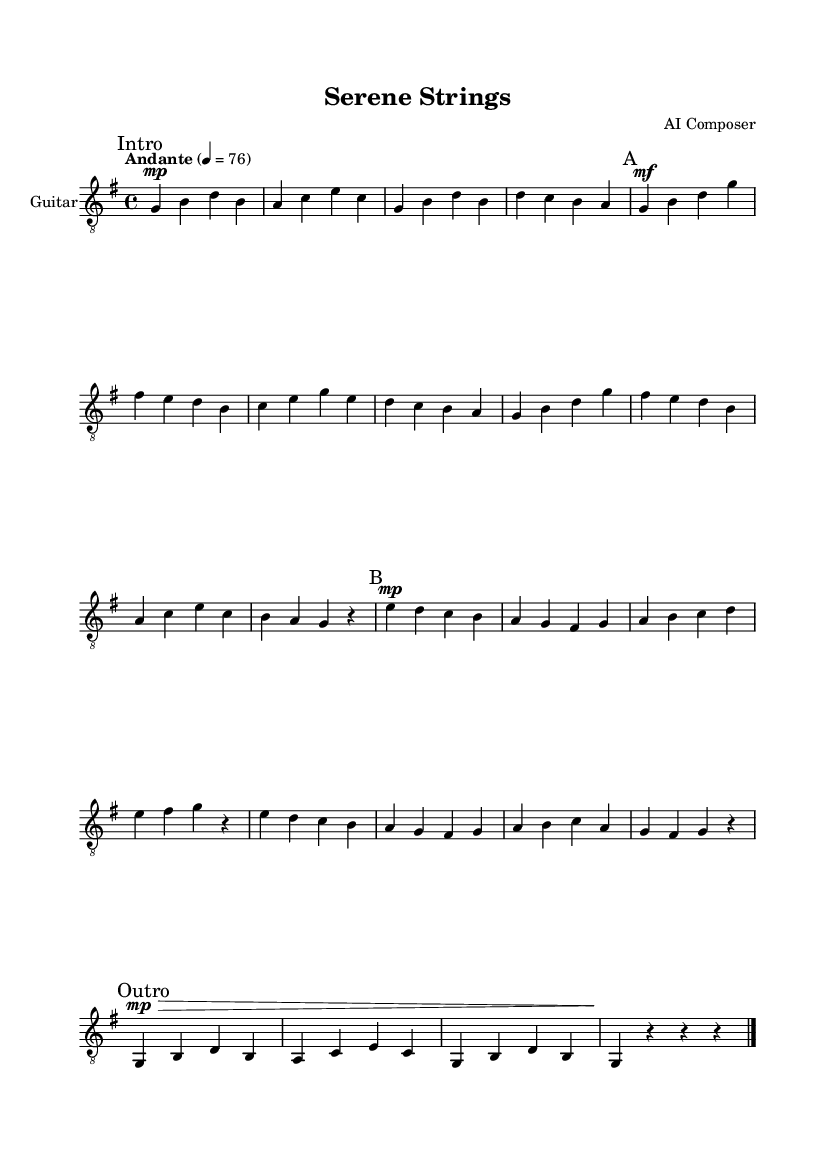What is the key signature of this music? The key signature is G major, which has one sharp (F#). This can be determined by looking at the key signature indicated at the beginning of the staff, which represents the notes that will be sharp throughout the piece.
Answer: G major What is the time signature of this music? The time signature is 4/4, as indicated at the beginning of the score. The top number (4) represents the number of beats in a measure, and the bottom number (4) indicates that a quarter note receives one beat.
Answer: 4/4 What is the tempo marking of this music? The tempo marking is "Andante" with a metronome marking of 76 beats per minute. This is shown at the beginning of the score and indicates a moderate pace for the piece.
Answer: Andante How many sections does this piece have? The piece consists of three sections labeled as "A," "B," and "Outro." These sections are indicated within the score by markings that denote different parts of the composition.
Answer: Three What is the dynamic level during Section A? The dynamic level during Section A is marked as "mf," which stands for mezzoforte, indicating a medium loud volume. This marking is placed above the first note of Section A to guide the performer on how to play.
Answer: mf What is the melody's highest note in Section B? The highest note in Section B is B, found in the first measure of the section. By analyzing the measures and comparing the notes played in Section B, we find that B is the highest pitch reached.
Answer: B Which section has a softer dynamic level? Section B has a softer dynamic level, indicated as "mp," which means mezzo-piano (moderately soft). This marking reveals that the section requires a gentler approach compared to the louder dynamics found in other sections.
Answer: mp 